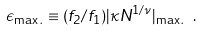<formula> <loc_0><loc_0><loc_500><loc_500>\epsilon _ { \max . } \equiv ( f _ { 2 } / f _ { 1 } ) | \kappa N ^ { 1 / \nu } | _ { \max . } \ .</formula> 